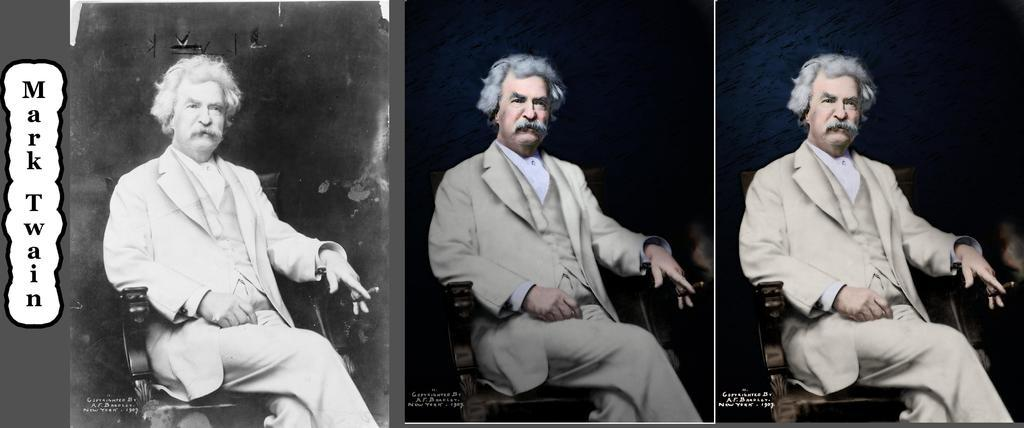How many people are in the image? There are three persons in the image. What are the persons doing in the image? The persons are sitting on chairs and walls. What type of cattle can be seen grazing in the image? There is no cattle present in the image; it features three persons sitting on chairs and walls. What type of space is visible in the image? The image does not depict any specific space, such as outer space or a room. 